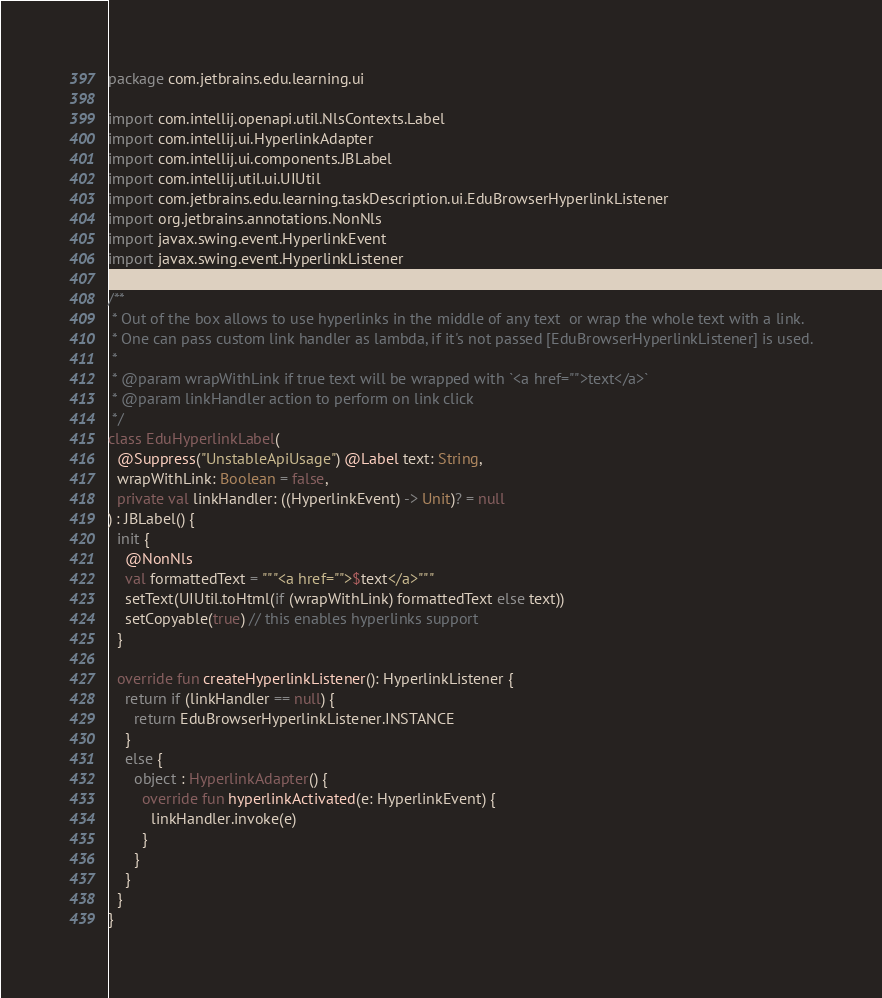<code> <loc_0><loc_0><loc_500><loc_500><_Kotlin_>package com.jetbrains.edu.learning.ui

import com.intellij.openapi.util.NlsContexts.Label
import com.intellij.ui.HyperlinkAdapter
import com.intellij.ui.components.JBLabel
import com.intellij.util.ui.UIUtil
import com.jetbrains.edu.learning.taskDescription.ui.EduBrowserHyperlinkListener
import org.jetbrains.annotations.NonNls
import javax.swing.event.HyperlinkEvent
import javax.swing.event.HyperlinkListener

/**
 * Out of the box allows to use hyperlinks in the middle of any text  or wrap the whole text with a link.
 * One can pass custom link handler as lambda, if it's not passed [EduBrowserHyperlinkListener] is used.
 *
 * @param wrapWithLink if true text will be wrapped with `<a href="">text</a>`
 * @param linkHandler action to perform on link click
 */
class EduHyperlinkLabel(
  @Suppress("UnstableApiUsage") @Label text: String,
  wrapWithLink: Boolean = false,
  private val linkHandler: ((HyperlinkEvent) -> Unit)? = null
) : JBLabel() {
  init {
    @NonNls
    val formattedText = """<a href="">$text</a>"""
    setText(UIUtil.toHtml(if (wrapWithLink) formattedText else text))
    setCopyable(true) // this enables hyperlinks support
  }

  override fun createHyperlinkListener(): HyperlinkListener {
    return if (linkHandler == null) {
      return EduBrowserHyperlinkListener.INSTANCE
    }
    else {
      object : HyperlinkAdapter() {
        override fun hyperlinkActivated(e: HyperlinkEvent) {
          linkHandler.invoke(e)
        }
      }
    }
  }
}</code> 